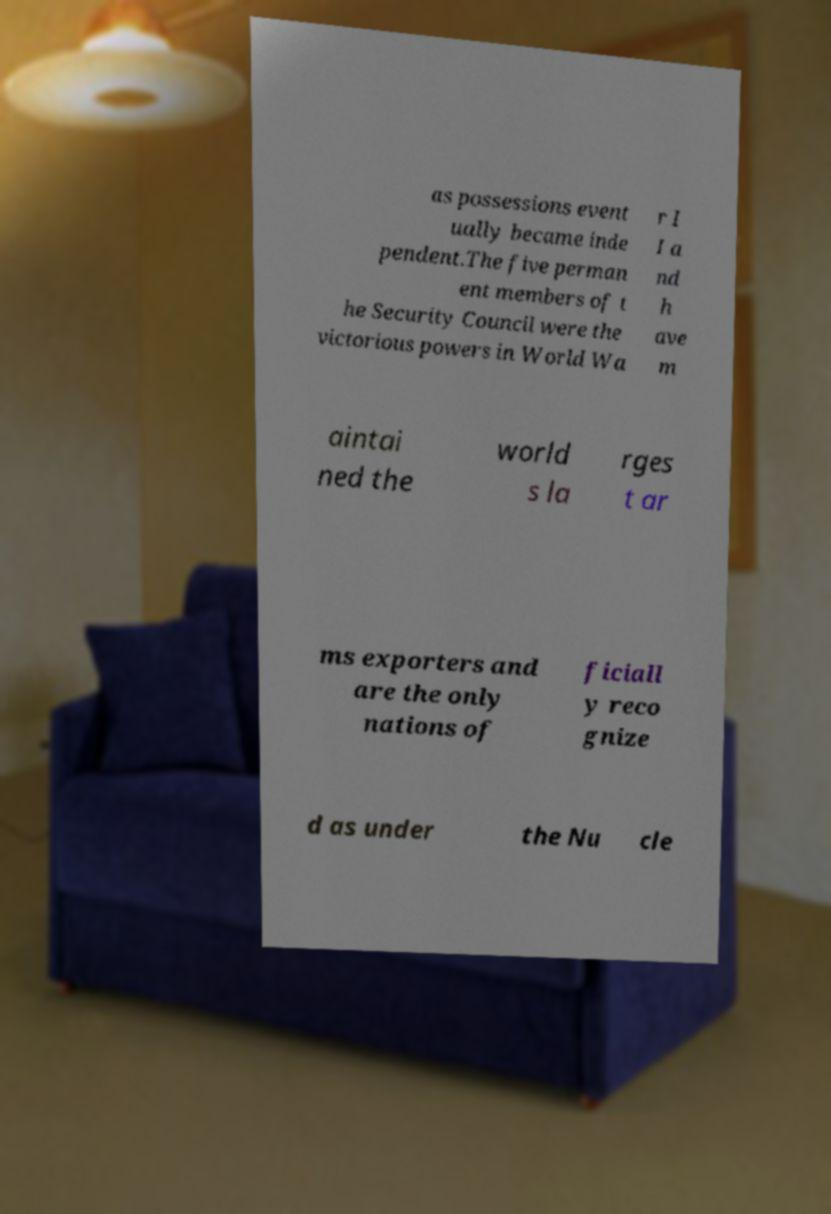Can you read and provide the text displayed in the image?This photo seems to have some interesting text. Can you extract and type it out for me? as possessions event ually became inde pendent.The five perman ent members of t he Security Council were the victorious powers in World Wa r I I a nd h ave m aintai ned the world s la rges t ar ms exporters and are the only nations of ficiall y reco gnize d as under the Nu cle 